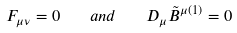<formula> <loc_0><loc_0><loc_500><loc_500>F _ { \mu \nu } = 0 \quad a n d \quad D _ { \mu } \tilde { B } ^ { \mu ( 1 ) } = 0</formula> 